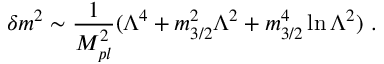<formula> <loc_0><loc_0><loc_500><loc_500>\delta m ^ { 2 } \sim { \frac { 1 } { M _ { p l } ^ { 2 } } } ( \Lambda ^ { 4 } + m _ { 3 / 2 } ^ { 2 } \Lambda ^ { 2 } + m _ { 3 / 2 } ^ { 4 } \ln \Lambda ^ { 2 } ) \ .</formula> 